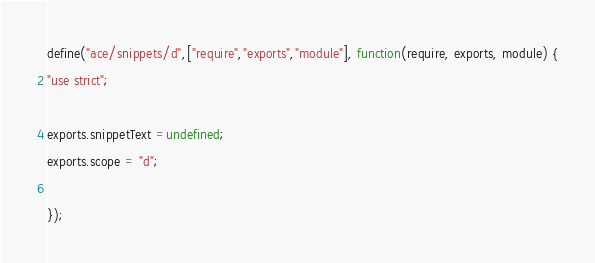Convert code to text. <code><loc_0><loc_0><loc_500><loc_500><_JavaScript_>define("ace/snippets/d",["require","exports","module"], function(require, exports, module) {
"use strict";

exports.snippetText =undefined;
exports.scope = "d";

});
</code> 